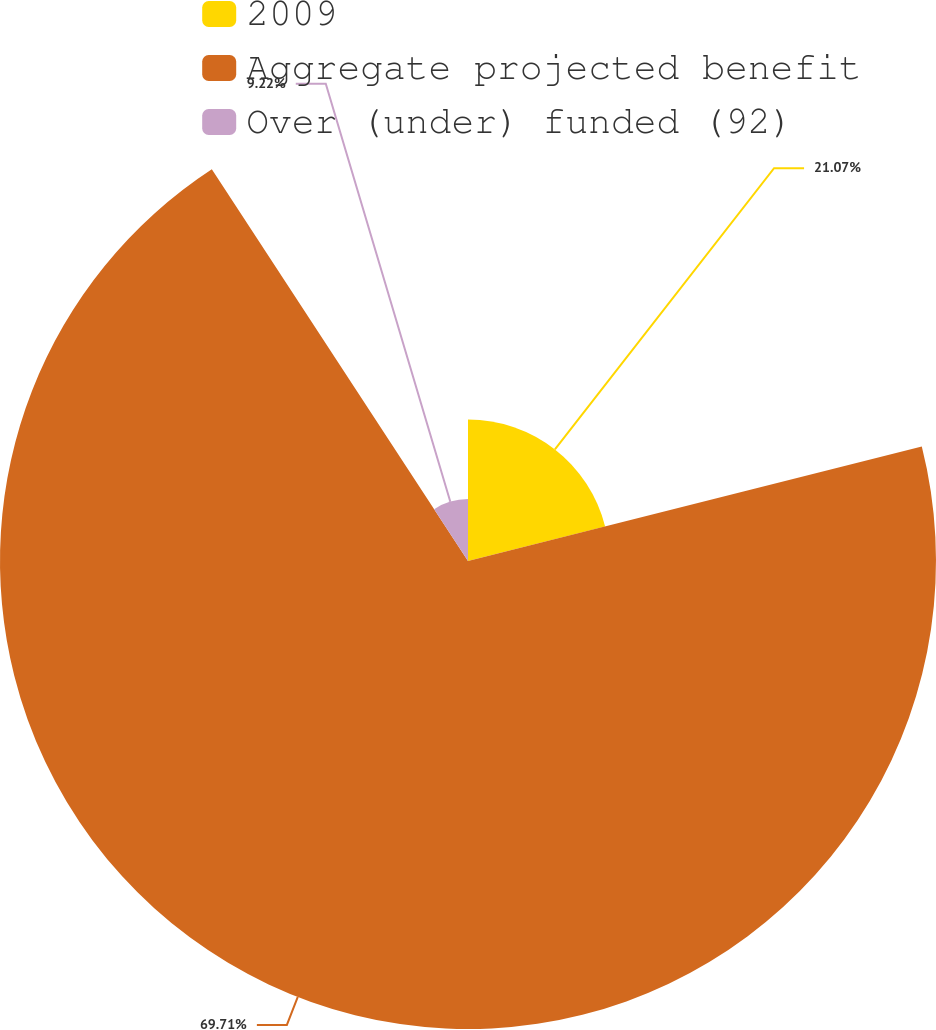Convert chart to OTSL. <chart><loc_0><loc_0><loc_500><loc_500><pie_chart><fcel>2009<fcel>Aggregate projected benefit<fcel>Over (under) funded (92)<nl><fcel>21.07%<fcel>69.72%<fcel>9.22%<nl></chart> 